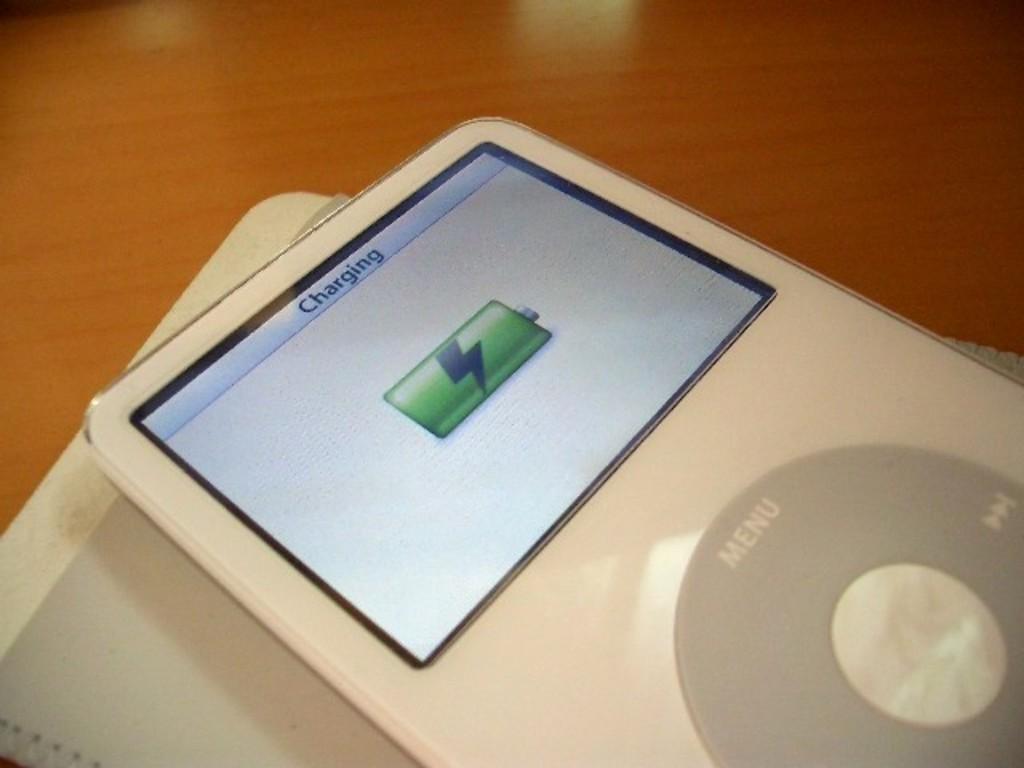Can you describe this image briefly? In the image there is a gadget, it is completely charged and the gadget is is placed on a book, under the book there is a table. 